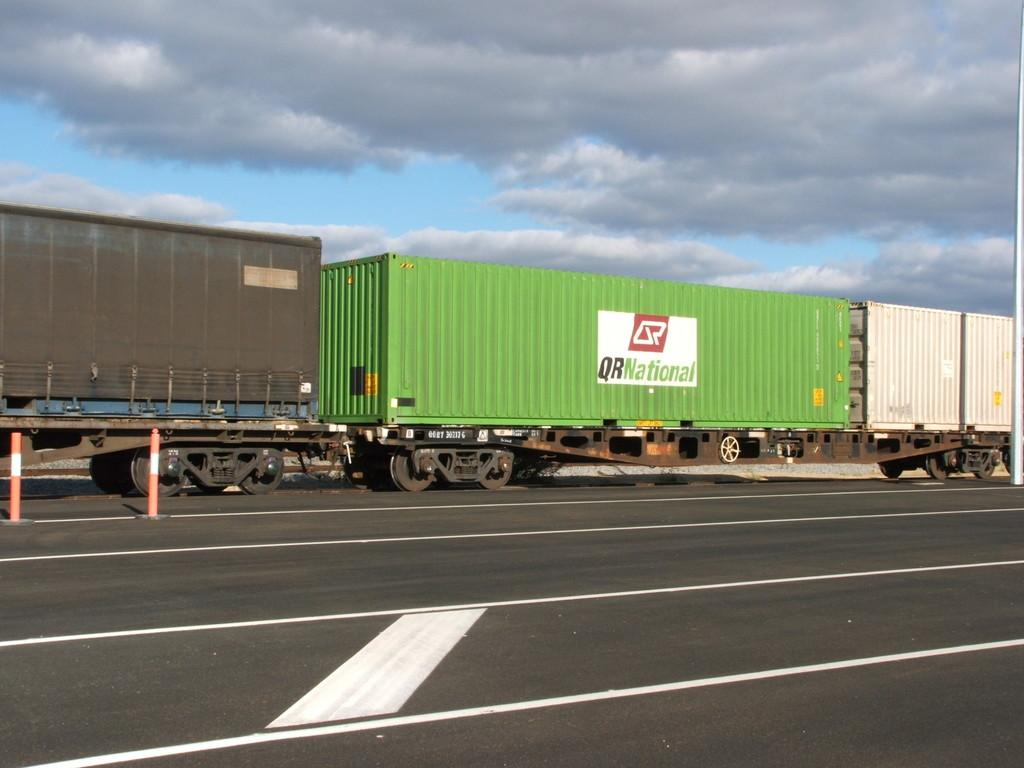What is the main subject in the center of the image? There is a vehicle in the center of the image. What is located at the bottom of the image? There is a road at the bottom of the image. What can be seen on the road in the image? There are barricades on the road. What is visible at the top of the image? The sky is visible at the top of the image. What type of bait is being used to catch birds in the image? There are no birds or bait present in the image. 